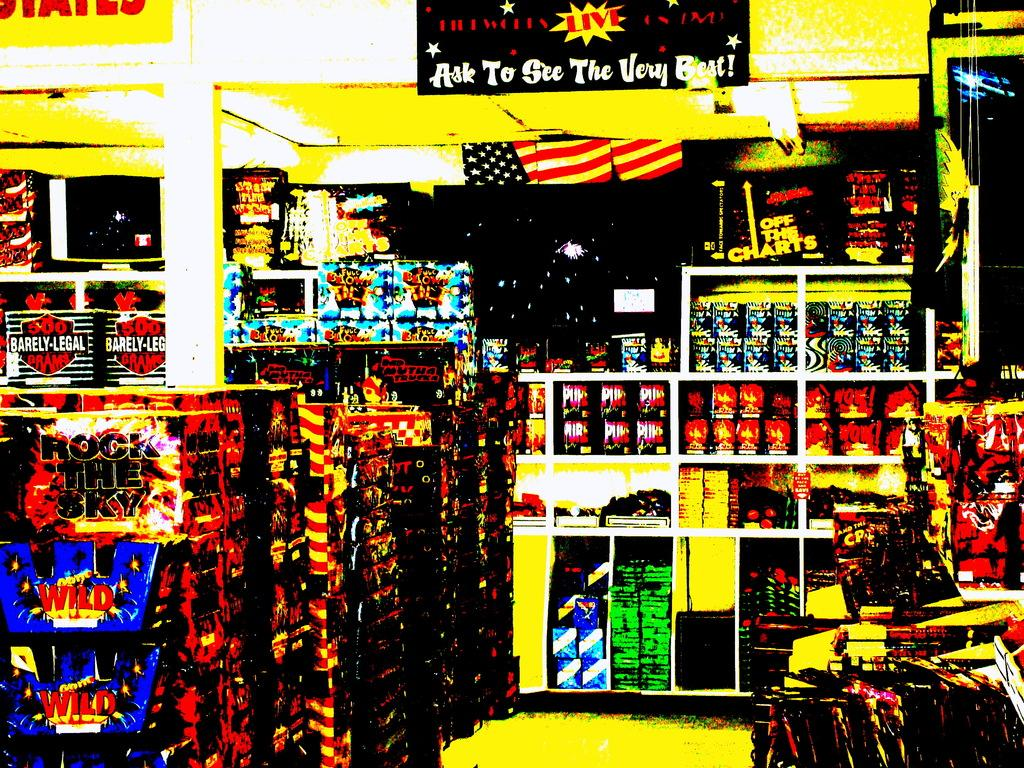<image>
Relay a brief, clear account of the picture shown. A store displays a sign that says to "Ask to see the very best." 